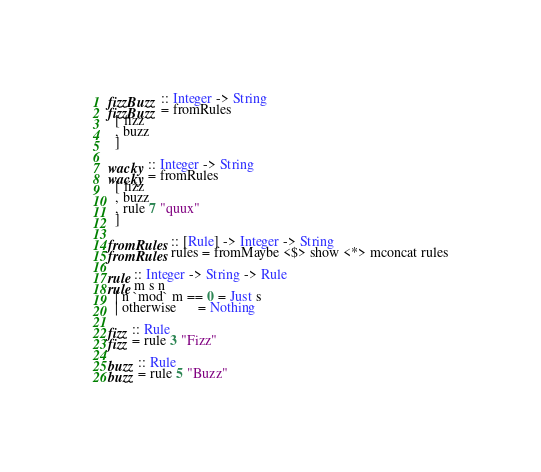Convert code to text. <code><loc_0><loc_0><loc_500><loc_500><_Haskell_>fizzBuzz :: Integer -> String
fizzBuzz = fromRules
  [ fizz
  , buzz
  ]

wacky :: Integer -> String
wacky = fromRules
  [ fizz
  , buzz
  , rule 7 "quux"
  ]

fromRules :: [Rule] -> Integer -> String
fromRules rules = fromMaybe <$> show <*> mconcat rules

rule :: Integer -> String -> Rule
rule m s n
  | n `mod` m == 0 = Just s
  | otherwise      = Nothing

fizz :: Rule
fizz = rule 3 "Fizz"

buzz :: Rule
buzz = rule 5 "Buzz"
</code> 